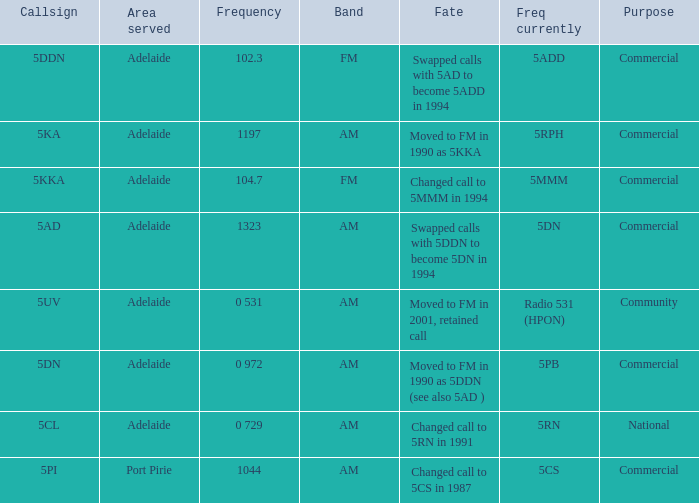What is the purpose for Frequency of 102.3? Commercial. 